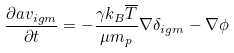Convert formula to latex. <formula><loc_0><loc_0><loc_500><loc_500>\frac { \partial a { v } _ { i g m } } { \partial t } = - \frac { \gamma k _ { B } \overline { T } } { \mu m _ { p } } \nabla \delta _ { i g m } - \nabla \phi</formula> 